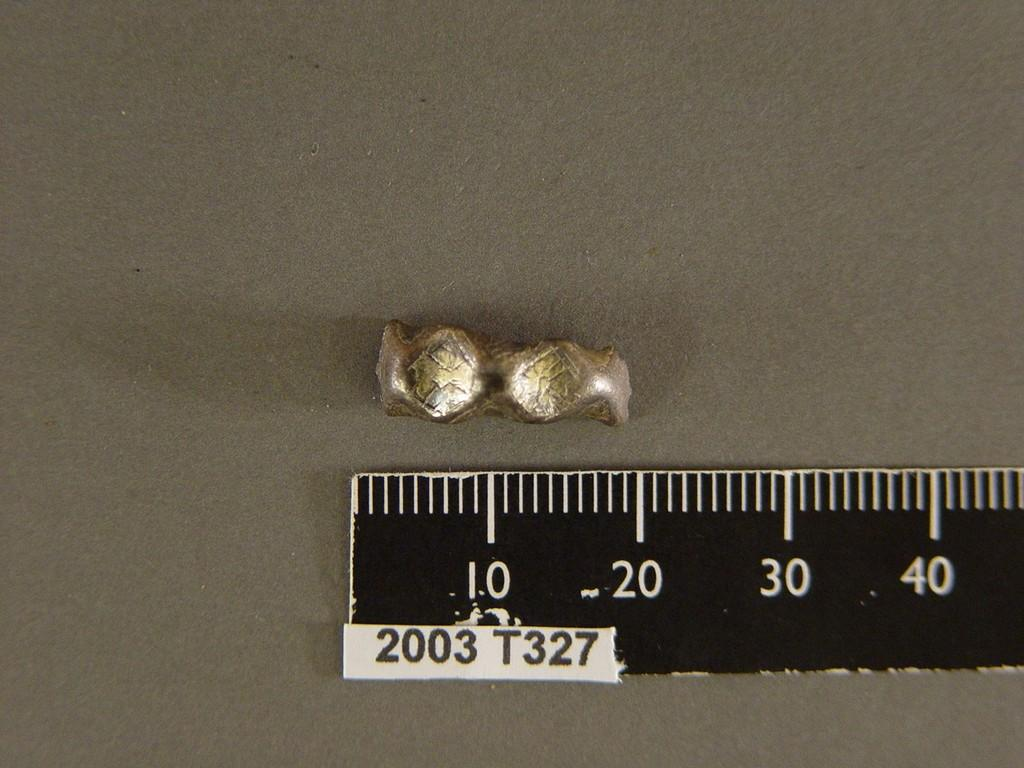Provide a one-sentence caption for the provided image. A 18mm slug of metal sits above a ruler labeled 2003 T327. 